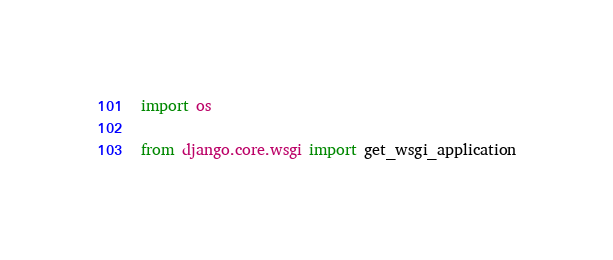<code> <loc_0><loc_0><loc_500><loc_500><_Python_>
import os

from django.core.wsgi import get_wsgi_application
</code> 